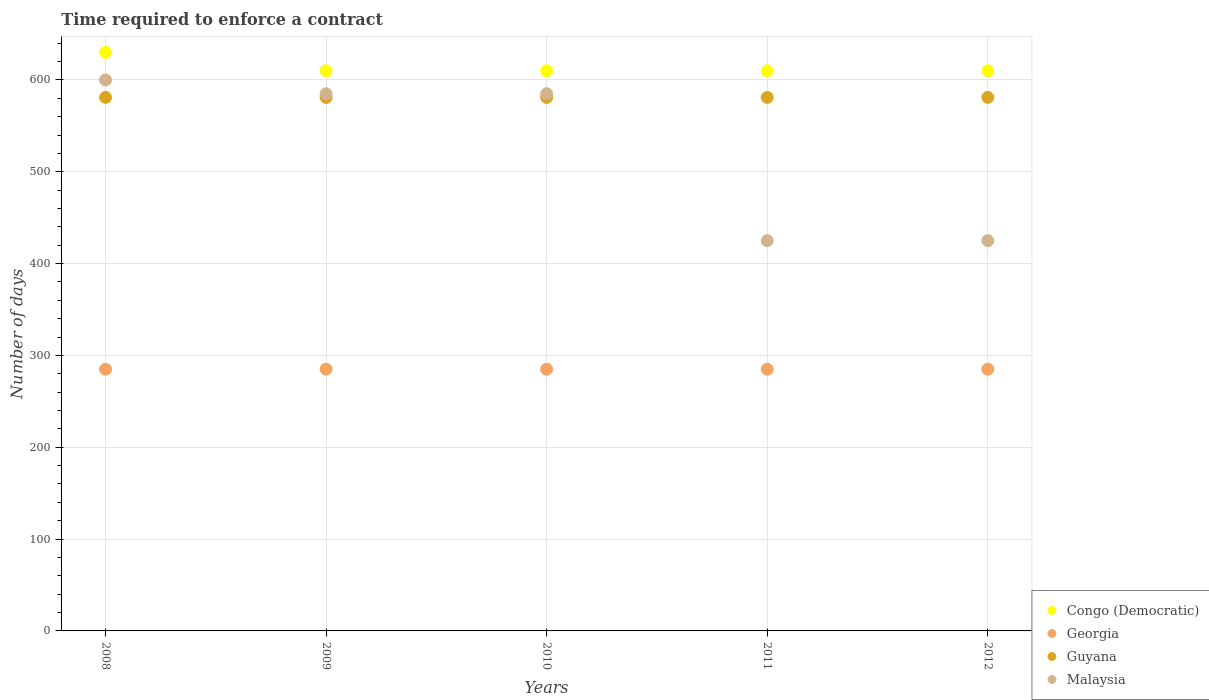How many different coloured dotlines are there?
Your answer should be compact. 4. What is the number of days required to enforce a contract in Congo (Democratic) in 2008?
Ensure brevity in your answer.  630. Across all years, what is the maximum number of days required to enforce a contract in Georgia?
Offer a very short reply. 285. Across all years, what is the minimum number of days required to enforce a contract in Congo (Democratic)?
Keep it short and to the point. 610. In which year was the number of days required to enforce a contract in Georgia maximum?
Give a very brief answer. 2008. In which year was the number of days required to enforce a contract in Congo (Democratic) minimum?
Give a very brief answer. 2009. What is the total number of days required to enforce a contract in Guyana in the graph?
Offer a very short reply. 2905. What is the difference between the number of days required to enforce a contract in Malaysia in 2009 and that in 2011?
Provide a short and direct response. 160. What is the average number of days required to enforce a contract in Guyana per year?
Make the answer very short. 581. In the year 2009, what is the difference between the number of days required to enforce a contract in Georgia and number of days required to enforce a contract in Congo (Democratic)?
Give a very brief answer. -325. Is the number of days required to enforce a contract in Guyana in 2008 less than that in 2009?
Your response must be concise. No. What is the difference between the highest and the second highest number of days required to enforce a contract in Georgia?
Provide a succinct answer. 0. Is the sum of the number of days required to enforce a contract in Guyana in 2010 and 2012 greater than the maximum number of days required to enforce a contract in Georgia across all years?
Provide a succinct answer. Yes. Does the number of days required to enforce a contract in Georgia monotonically increase over the years?
Offer a very short reply. No. Where does the legend appear in the graph?
Your answer should be compact. Bottom right. What is the title of the graph?
Your answer should be compact. Time required to enforce a contract. Does "Dominica" appear as one of the legend labels in the graph?
Provide a succinct answer. No. What is the label or title of the Y-axis?
Your response must be concise. Number of days. What is the Number of days of Congo (Democratic) in 2008?
Ensure brevity in your answer.  630. What is the Number of days of Georgia in 2008?
Give a very brief answer. 285. What is the Number of days of Guyana in 2008?
Offer a terse response. 581. What is the Number of days of Malaysia in 2008?
Your answer should be compact. 600. What is the Number of days of Congo (Democratic) in 2009?
Make the answer very short. 610. What is the Number of days in Georgia in 2009?
Offer a terse response. 285. What is the Number of days in Guyana in 2009?
Provide a short and direct response. 581. What is the Number of days in Malaysia in 2009?
Your answer should be very brief. 585. What is the Number of days in Congo (Democratic) in 2010?
Make the answer very short. 610. What is the Number of days in Georgia in 2010?
Offer a terse response. 285. What is the Number of days in Guyana in 2010?
Provide a succinct answer. 581. What is the Number of days of Malaysia in 2010?
Offer a terse response. 585. What is the Number of days in Congo (Democratic) in 2011?
Keep it short and to the point. 610. What is the Number of days in Georgia in 2011?
Your answer should be very brief. 285. What is the Number of days of Guyana in 2011?
Your response must be concise. 581. What is the Number of days of Malaysia in 2011?
Make the answer very short. 425. What is the Number of days in Congo (Democratic) in 2012?
Provide a short and direct response. 610. What is the Number of days of Georgia in 2012?
Provide a succinct answer. 285. What is the Number of days of Guyana in 2012?
Offer a terse response. 581. What is the Number of days of Malaysia in 2012?
Your answer should be very brief. 425. Across all years, what is the maximum Number of days in Congo (Democratic)?
Provide a short and direct response. 630. Across all years, what is the maximum Number of days in Georgia?
Keep it short and to the point. 285. Across all years, what is the maximum Number of days in Guyana?
Provide a succinct answer. 581. Across all years, what is the maximum Number of days in Malaysia?
Offer a terse response. 600. Across all years, what is the minimum Number of days in Congo (Democratic)?
Your answer should be very brief. 610. Across all years, what is the minimum Number of days in Georgia?
Provide a short and direct response. 285. Across all years, what is the minimum Number of days in Guyana?
Make the answer very short. 581. Across all years, what is the minimum Number of days of Malaysia?
Provide a short and direct response. 425. What is the total Number of days in Congo (Democratic) in the graph?
Your answer should be very brief. 3070. What is the total Number of days of Georgia in the graph?
Ensure brevity in your answer.  1425. What is the total Number of days in Guyana in the graph?
Ensure brevity in your answer.  2905. What is the total Number of days in Malaysia in the graph?
Your answer should be very brief. 2620. What is the difference between the Number of days in Georgia in 2008 and that in 2009?
Your answer should be very brief. 0. What is the difference between the Number of days in Malaysia in 2008 and that in 2009?
Provide a short and direct response. 15. What is the difference between the Number of days of Malaysia in 2008 and that in 2010?
Ensure brevity in your answer.  15. What is the difference between the Number of days of Malaysia in 2008 and that in 2011?
Your answer should be compact. 175. What is the difference between the Number of days of Georgia in 2008 and that in 2012?
Keep it short and to the point. 0. What is the difference between the Number of days in Guyana in 2008 and that in 2012?
Your response must be concise. 0. What is the difference between the Number of days of Malaysia in 2008 and that in 2012?
Your answer should be compact. 175. What is the difference between the Number of days in Georgia in 2009 and that in 2010?
Provide a short and direct response. 0. What is the difference between the Number of days in Malaysia in 2009 and that in 2011?
Provide a short and direct response. 160. What is the difference between the Number of days of Georgia in 2009 and that in 2012?
Your response must be concise. 0. What is the difference between the Number of days in Malaysia in 2009 and that in 2012?
Make the answer very short. 160. What is the difference between the Number of days of Congo (Democratic) in 2010 and that in 2011?
Provide a succinct answer. 0. What is the difference between the Number of days in Malaysia in 2010 and that in 2011?
Make the answer very short. 160. What is the difference between the Number of days in Congo (Democratic) in 2010 and that in 2012?
Your answer should be very brief. 0. What is the difference between the Number of days of Guyana in 2010 and that in 2012?
Provide a short and direct response. 0. What is the difference between the Number of days of Malaysia in 2010 and that in 2012?
Your answer should be very brief. 160. What is the difference between the Number of days of Congo (Democratic) in 2011 and that in 2012?
Ensure brevity in your answer.  0. What is the difference between the Number of days of Guyana in 2011 and that in 2012?
Provide a succinct answer. 0. What is the difference between the Number of days of Congo (Democratic) in 2008 and the Number of days of Georgia in 2009?
Keep it short and to the point. 345. What is the difference between the Number of days of Congo (Democratic) in 2008 and the Number of days of Guyana in 2009?
Make the answer very short. 49. What is the difference between the Number of days in Congo (Democratic) in 2008 and the Number of days in Malaysia in 2009?
Your answer should be very brief. 45. What is the difference between the Number of days of Georgia in 2008 and the Number of days of Guyana in 2009?
Provide a short and direct response. -296. What is the difference between the Number of days of Georgia in 2008 and the Number of days of Malaysia in 2009?
Offer a terse response. -300. What is the difference between the Number of days of Guyana in 2008 and the Number of days of Malaysia in 2009?
Provide a succinct answer. -4. What is the difference between the Number of days of Congo (Democratic) in 2008 and the Number of days of Georgia in 2010?
Give a very brief answer. 345. What is the difference between the Number of days of Georgia in 2008 and the Number of days of Guyana in 2010?
Your response must be concise. -296. What is the difference between the Number of days of Georgia in 2008 and the Number of days of Malaysia in 2010?
Your answer should be compact. -300. What is the difference between the Number of days of Congo (Democratic) in 2008 and the Number of days of Georgia in 2011?
Provide a succinct answer. 345. What is the difference between the Number of days of Congo (Democratic) in 2008 and the Number of days of Guyana in 2011?
Give a very brief answer. 49. What is the difference between the Number of days of Congo (Democratic) in 2008 and the Number of days of Malaysia in 2011?
Offer a very short reply. 205. What is the difference between the Number of days of Georgia in 2008 and the Number of days of Guyana in 2011?
Offer a very short reply. -296. What is the difference between the Number of days of Georgia in 2008 and the Number of days of Malaysia in 2011?
Your answer should be very brief. -140. What is the difference between the Number of days of Guyana in 2008 and the Number of days of Malaysia in 2011?
Offer a terse response. 156. What is the difference between the Number of days of Congo (Democratic) in 2008 and the Number of days of Georgia in 2012?
Provide a short and direct response. 345. What is the difference between the Number of days in Congo (Democratic) in 2008 and the Number of days in Guyana in 2012?
Your answer should be compact. 49. What is the difference between the Number of days in Congo (Democratic) in 2008 and the Number of days in Malaysia in 2012?
Offer a terse response. 205. What is the difference between the Number of days in Georgia in 2008 and the Number of days in Guyana in 2012?
Give a very brief answer. -296. What is the difference between the Number of days of Georgia in 2008 and the Number of days of Malaysia in 2012?
Keep it short and to the point. -140. What is the difference between the Number of days of Guyana in 2008 and the Number of days of Malaysia in 2012?
Your answer should be very brief. 156. What is the difference between the Number of days of Congo (Democratic) in 2009 and the Number of days of Georgia in 2010?
Provide a short and direct response. 325. What is the difference between the Number of days in Congo (Democratic) in 2009 and the Number of days in Guyana in 2010?
Your response must be concise. 29. What is the difference between the Number of days of Congo (Democratic) in 2009 and the Number of days of Malaysia in 2010?
Ensure brevity in your answer.  25. What is the difference between the Number of days in Georgia in 2009 and the Number of days in Guyana in 2010?
Make the answer very short. -296. What is the difference between the Number of days in Georgia in 2009 and the Number of days in Malaysia in 2010?
Ensure brevity in your answer.  -300. What is the difference between the Number of days of Congo (Democratic) in 2009 and the Number of days of Georgia in 2011?
Ensure brevity in your answer.  325. What is the difference between the Number of days of Congo (Democratic) in 2009 and the Number of days of Malaysia in 2011?
Provide a short and direct response. 185. What is the difference between the Number of days in Georgia in 2009 and the Number of days in Guyana in 2011?
Provide a short and direct response. -296. What is the difference between the Number of days in Georgia in 2009 and the Number of days in Malaysia in 2011?
Offer a terse response. -140. What is the difference between the Number of days in Guyana in 2009 and the Number of days in Malaysia in 2011?
Your answer should be very brief. 156. What is the difference between the Number of days of Congo (Democratic) in 2009 and the Number of days of Georgia in 2012?
Your answer should be very brief. 325. What is the difference between the Number of days in Congo (Democratic) in 2009 and the Number of days in Guyana in 2012?
Make the answer very short. 29. What is the difference between the Number of days in Congo (Democratic) in 2009 and the Number of days in Malaysia in 2012?
Your answer should be very brief. 185. What is the difference between the Number of days in Georgia in 2009 and the Number of days in Guyana in 2012?
Your answer should be very brief. -296. What is the difference between the Number of days in Georgia in 2009 and the Number of days in Malaysia in 2012?
Offer a terse response. -140. What is the difference between the Number of days in Guyana in 2009 and the Number of days in Malaysia in 2012?
Provide a short and direct response. 156. What is the difference between the Number of days in Congo (Democratic) in 2010 and the Number of days in Georgia in 2011?
Provide a short and direct response. 325. What is the difference between the Number of days of Congo (Democratic) in 2010 and the Number of days of Guyana in 2011?
Your answer should be compact. 29. What is the difference between the Number of days of Congo (Democratic) in 2010 and the Number of days of Malaysia in 2011?
Make the answer very short. 185. What is the difference between the Number of days of Georgia in 2010 and the Number of days of Guyana in 2011?
Your answer should be very brief. -296. What is the difference between the Number of days in Georgia in 2010 and the Number of days in Malaysia in 2011?
Offer a terse response. -140. What is the difference between the Number of days in Guyana in 2010 and the Number of days in Malaysia in 2011?
Your answer should be compact. 156. What is the difference between the Number of days in Congo (Democratic) in 2010 and the Number of days in Georgia in 2012?
Offer a terse response. 325. What is the difference between the Number of days of Congo (Democratic) in 2010 and the Number of days of Malaysia in 2012?
Ensure brevity in your answer.  185. What is the difference between the Number of days of Georgia in 2010 and the Number of days of Guyana in 2012?
Provide a short and direct response. -296. What is the difference between the Number of days in Georgia in 2010 and the Number of days in Malaysia in 2012?
Keep it short and to the point. -140. What is the difference between the Number of days of Guyana in 2010 and the Number of days of Malaysia in 2012?
Ensure brevity in your answer.  156. What is the difference between the Number of days in Congo (Democratic) in 2011 and the Number of days in Georgia in 2012?
Make the answer very short. 325. What is the difference between the Number of days in Congo (Democratic) in 2011 and the Number of days in Guyana in 2012?
Provide a short and direct response. 29. What is the difference between the Number of days in Congo (Democratic) in 2011 and the Number of days in Malaysia in 2012?
Your answer should be compact. 185. What is the difference between the Number of days of Georgia in 2011 and the Number of days of Guyana in 2012?
Offer a terse response. -296. What is the difference between the Number of days of Georgia in 2011 and the Number of days of Malaysia in 2012?
Your response must be concise. -140. What is the difference between the Number of days in Guyana in 2011 and the Number of days in Malaysia in 2012?
Provide a short and direct response. 156. What is the average Number of days of Congo (Democratic) per year?
Your answer should be very brief. 614. What is the average Number of days of Georgia per year?
Offer a very short reply. 285. What is the average Number of days of Guyana per year?
Offer a terse response. 581. What is the average Number of days in Malaysia per year?
Your answer should be compact. 524. In the year 2008, what is the difference between the Number of days in Congo (Democratic) and Number of days in Georgia?
Offer a very short reply. 345. In the year 2008, what is the difference between the Number of days in Congo (Democratic) and Number of days in Guyana?
Offer a terse response. 49. In the year 2008, what is the difference between the Number of days in Congo (Democratic) and Number of days in Malaysia?
Offer a very short reply. 30. In the year 2008, what is the difference between the Number of days of Georgia and Number of days of Guyana?
Offer a very short reply. -296. In the year 2008, what is the difference between the Number of days in Georgia and Number of days in Malaysia?
Keep it short and to the point. -315. In the year 2008, what is the difference between the Number of days in Guyana and Number of days in Malaysia?
Your answer should be very brief. -19. In the year 2009, what is the difference between the Number of days in Congo (Democratic) and Number of days in Georgia?
Your answer should be compact. 325. In the year 2009, what is the difference between the Number of days of Congo (Democratic) and Number of days of Guyana?
Provide a succinct answer. 29. In the year 2009, what is the difference between the Number of days in Congo (Democratic) and Number of days in Malaysia?
Your response must be concise. 25. In the year 2009, what is the difference between the Number of days of Georgia and Number of days of Guyana?
Provide a short and direct response. -296. In the year 2009, what is the difference between the Number of days of Georgia and Number of days of Malaysia?
Provide a succinct answer. -300. In the year 2009, what is the difference between the Number of days of Guyana and Number of days of Malaysia?
Offer a terse response. -4. In the year 2010, what is the difference between the Number of days in Congo (Democratic) and Number of days in Georgia?
Make the answer very short. 325. In the year 2010, what is the difference between the Number of days in Congo (Democratic) and Number of days in Guyana?
Make the answer very short. 29. In the year 2010, what is the difference between the Number of days in Congo (Democratic) and Number of days in Malaysia?
Ensure brevity in your answer.  25. In the year 2010, what is the difference between the Number of days in Georgia and Number of days in Guyana?
Make the answer very short. -296. In the year 2010, what is the difference between the Number of days of Georgia and Number of days of Malaysia?
Your response must be concise. -300. In the year 2011, what is the difference between the Number of days of Congo (Democratic) and Number of days of Georgia?
Your answer should be very brief. 325. In the year 2011, what is the difference between the Number of days of Congo (Democratic) and Number of days of Malaysia?
Your answer should be very brief. 185. In the year 2011, what is the difference between the Number of days of Georgia and Number of days of Guyana?
Offer a terse response. -296. In the year 2011, what is the difference between the Number of days in Georgia and Number of days in Malaysia?
Offer a very short reply. -140. In the year 2011, what is the difference between the Number of days in Guyana and Number of days in Malaysia?
Make the answer very short. 156. In the year 2012, what is the difference between the Number of days in Congo (Democratic) and Number of days in Georgia?
Keep it short and to the point. 325. In the year 2012, what is the difference between the Number of days of Congo (Democratic) and Number of days of Malaysia?
Keep it short and to the point. 185. In the year 2012, what is the difference between the Number of days in Georgia and Number of days in Guyana?
Provide a succinct answer. -296. In the year 2012, what is the difference between the Number of days of Georgia and Number of days of Malaysia?
Offer a terse response. -140. In the year 2012, what is the difference between the Number of days in Guyana and Number of days in Malaysia?
Offer a terse response. 156. What is the ratio of the Number of days of Congo (Democratic) in 2008 to that in 2009?
Give a very brief answer. 1.03. What is the ratio of the Number of days in Georgia in 2008 to that in 2009?
Give a very brief answer. 1. What is the ratio of the Number of days in Guyana in 2008 to that in 2009?
Ensure brevity in your answer.  1. What is the ratio of the Number of days in Malaysia in 2008 to that in 2009?
Your answer should be very brief. 1.03. What is the ratio of the Number of days of Congo (Democratic) in 2008 to that in 2010?
Offer a terse response. 1.03. What is the ratio of the Number of days in Georgia in 2008 to that in 2010?
Provide a succinct answer. 1. What is the ratio of the Number of days of Malaysia in 2008 to that in 2010?
Offer a terse response. 1.03. What is the ratio of the Number of days in Congo (Democratic) in 2008 to that in 2011?
Offer a very short reply. 1.03. What is the ratio of the Number of days of Malaysia in 2008 to that in 2011?
Offer a very short reply. 1.41. What is the ratio of the Number of days in Congo (Democratic) in 2008 to that in 2012?
Make the answer very short. 1.03. What is the ratio of the Number of days in Georgia in 2008 to that in 2012?
Your response must be concise. 1. What is the ratio of the Number of days of Malaysia in 2008 to that in 2012?
Provide a succinct answer. 1.41. What is the ratio of the Number of days of Georgia in 2009 to that in 2010?
Your response must be concise. 1. What is the ratio of the Number of days of Malaysia in 2009 to that in 2010?
Provide a short and direct response. 1. What is the ratio of the Number of days in Georgia in 2009 to that in 2011?
Your response must be concise. 1. What is the ratio of the Number of days in Guyana in 2009 to that in 2011?
Offer a terse response. 1. What is the ratio of the Number of days in Malaysia in 2009 to that in 2011?
Keep it short and to the point. 1.38. What is the ratio of the Number of days of Congo (Democratic) in 2009 to that in 2012?
Offer a terse response. 1. What is the ratio of the Number of days of Georgia in 2009 to that in 2012?
Keep it short and to the point. 1. What is the ratio of the Number of days in Malaysia in 2009 to that in 2012?
Ensure brevity in your answer.  1.38. What is the ratio of the Number of days of Georgia in 2010 to that in 2011?
Provide a succinct answer. 1. What is the ratio of the Number of days of Malaysia in 2010 to that in 2011?
Your response must be concise. 1.38. What is the ratio of the Number of days in Guyana in 2010 to that in 2012?
Your response must be concise. 1. What is the ratio of the Number of days of Malaysia in 2010 to that in 2012?
Your answer should be compact. 1.38. What is the difference between the highest and the second highest Number of days of Congo (Democratic)?
Provide a short and direct response. 20. What is the difference between the highest and the second highest Number of days in Guyana?
Offer a terse response. 0. What is the difference between the highest and the second highest Number of days in Malaysia?
Your answer should be compact. 15. What is the difference between the highest and the lowest Number of days of Congo (Democratic)?
Ensure brevity in your answer.  20. What is the difference between the highest and the lowest Number of days of Georgia?
Offer a terse response. 0. What is the difference between the highest and the lowest Number of days in Guyana?
Provide a succinct answer. 0. What is the difference between the highest and the lowest Number of days of Malaysia?
Make the answer very short. 175. 